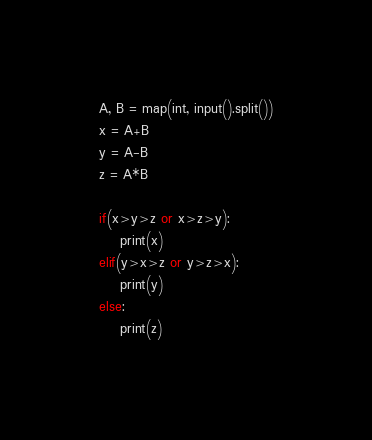Convert code to text. <code><loc_0><loc_0><loc_500><loc_500><_Python_>A, B = map(int, input().split())
x = A+B
y = A-B
z = A*B

if(x>y>z or x>z>y):
    print(x)
elif(y>x>z or y>z>x):
    print(y)
else:
    print(z)</code> 